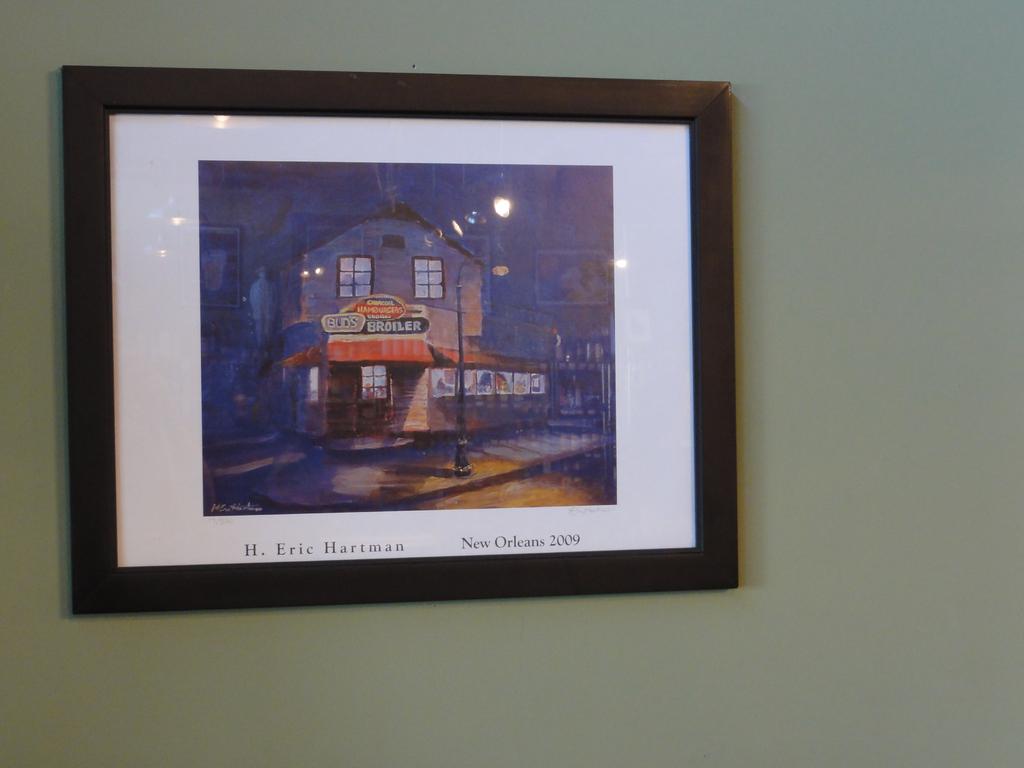Who painted the picture?
Offer a terse response. H. eric hartman. What year is on the painting?
Provide a short and direct response. 2009. 